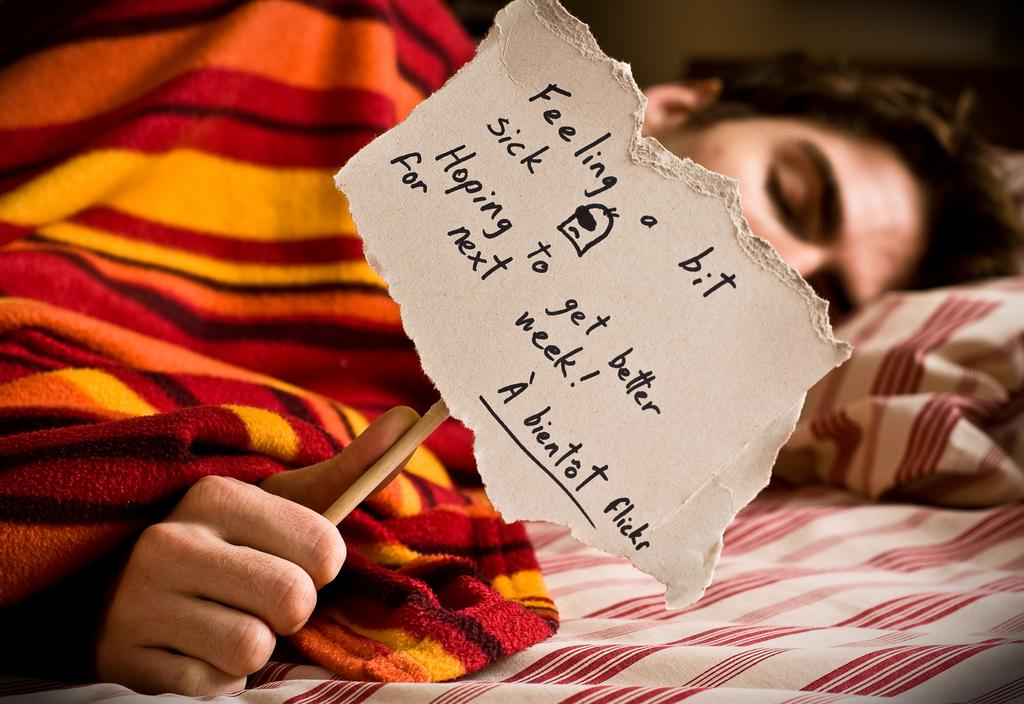Who is the main subject in the picture? There is a boy in the picture. What is the boy doing in the image? The boy is sleeping on the bed. What is covering the bed in the image? The bed has a colorful blanket on top. What is the boy holding in his hand? The boy is holding a small notice in his hand. What type of nest can be seen in the picture? There is no nest present in the picture; it features a boy sleeping on a bed with a colorful blanket and holding a small notice. 